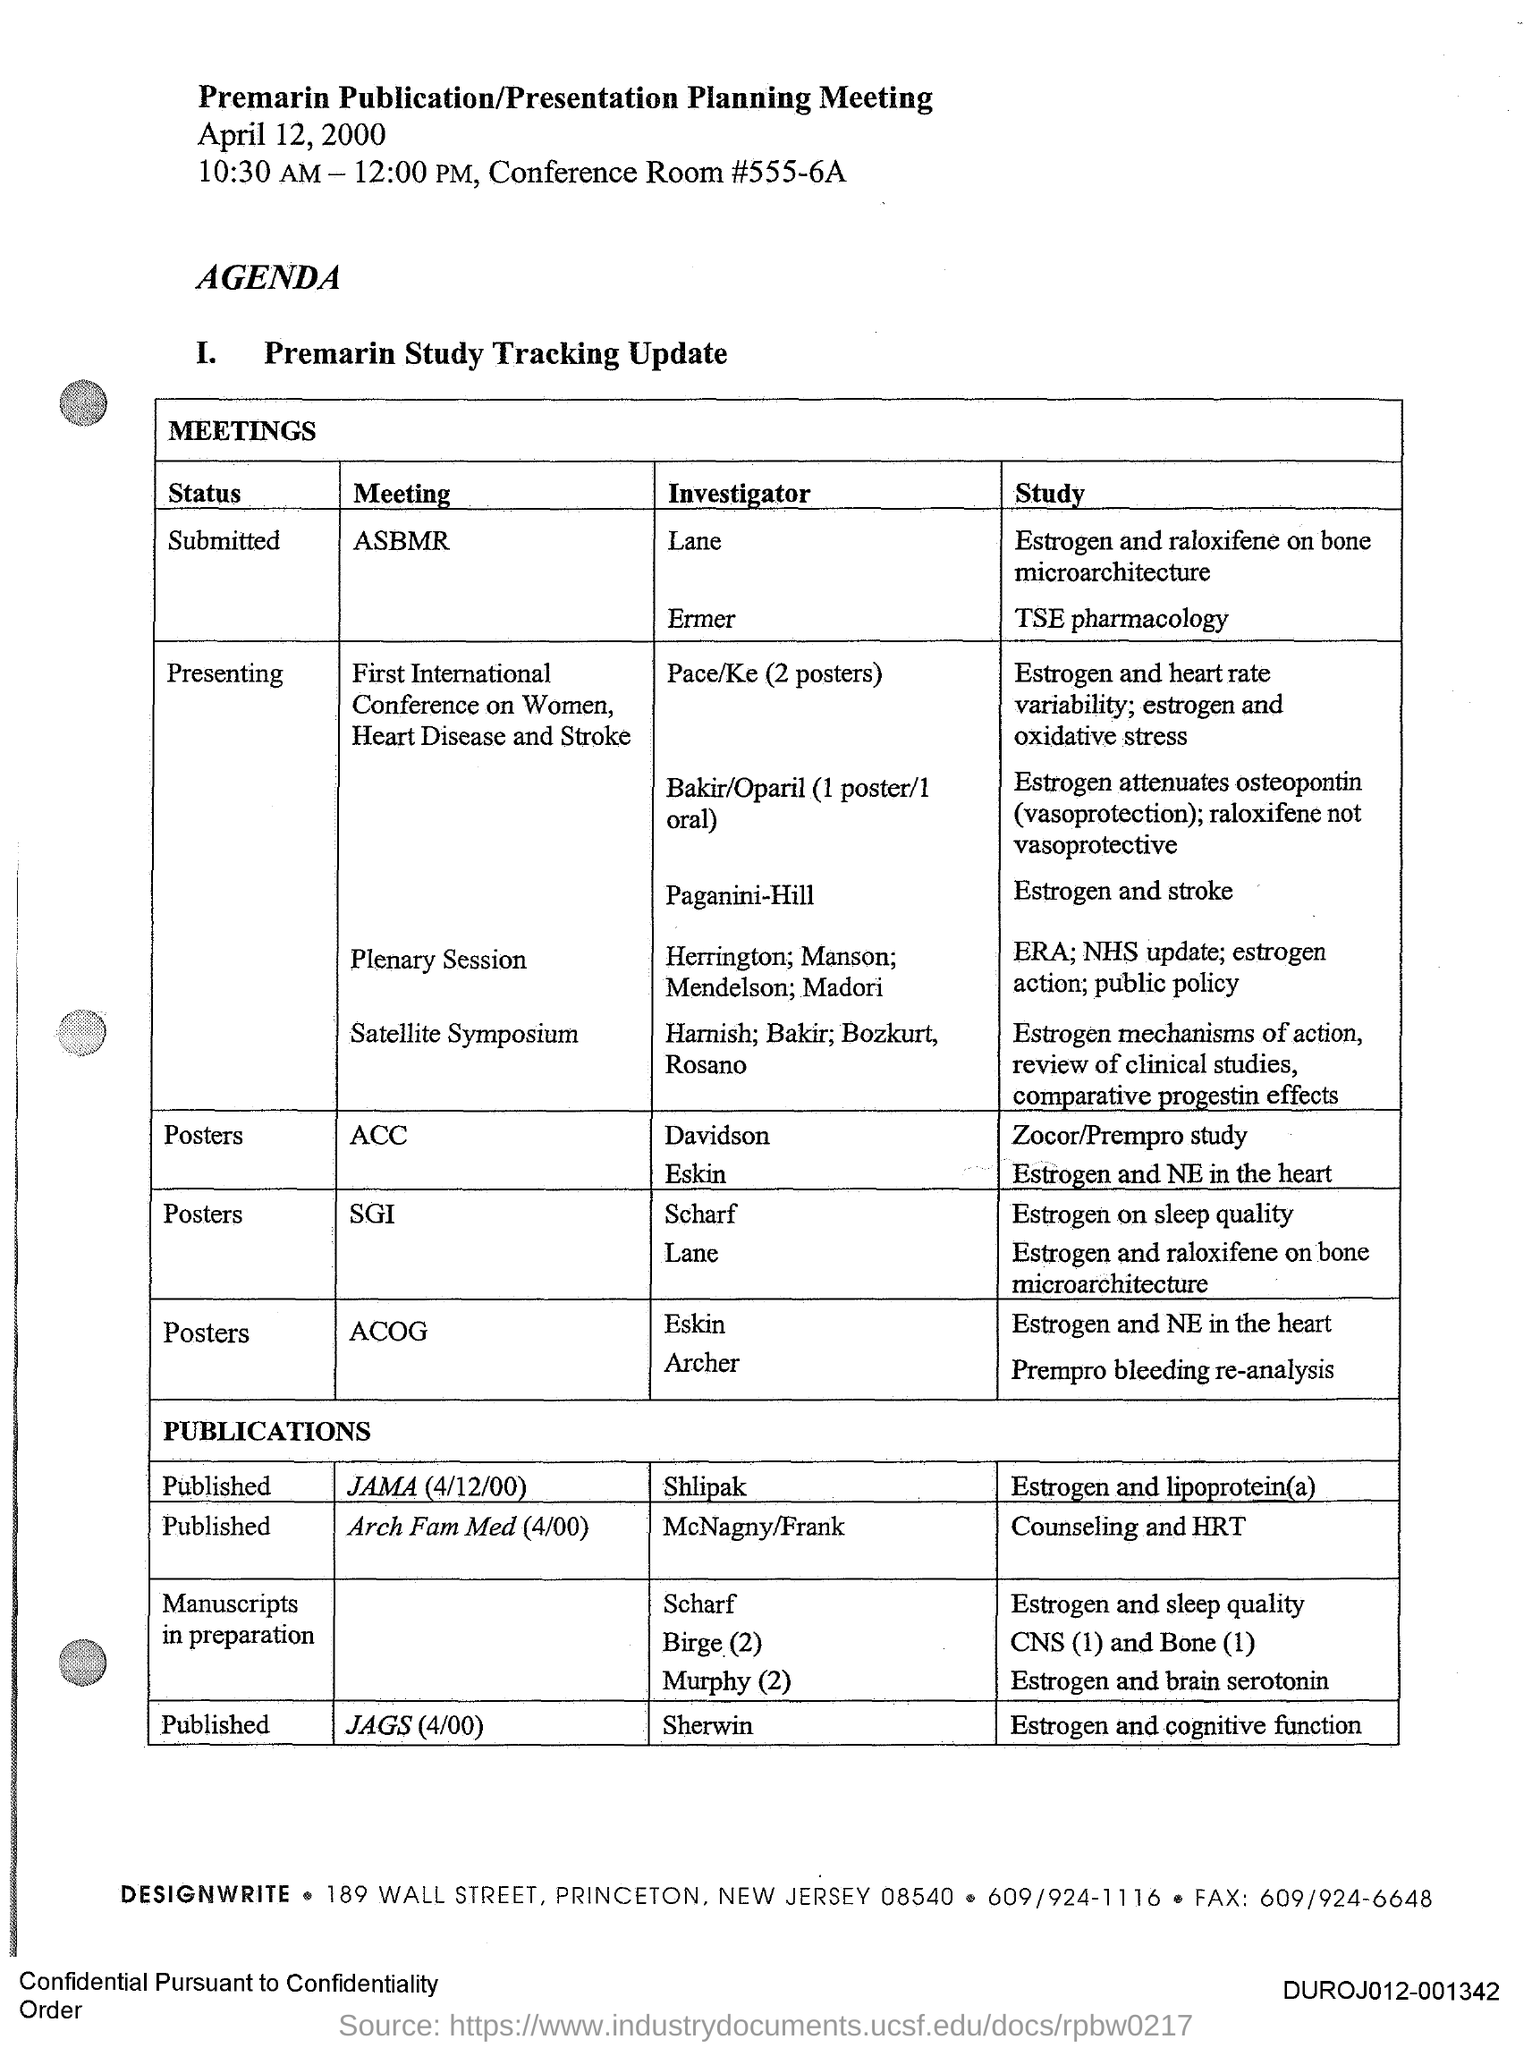Identify some key points in this picture. The investigator of the meeting publication in JAMA on April 12, 2000, is Shlipak. The title of the document is "Premarin Publication/Presentation Planning Meeting." The status of the meeting "ASBMR" is currently submitted. The status of the meeting called "ACC" is currently unknown to posters. 